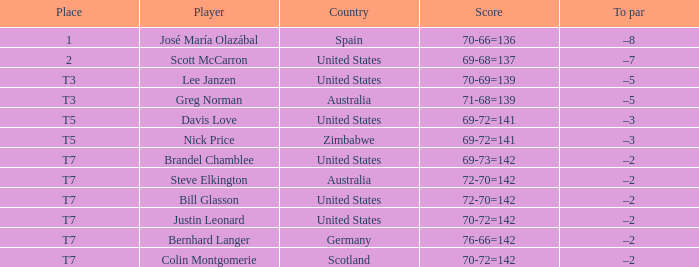Which score holds an under par of -3, and a nation belonging to united states? 69-72=141. 